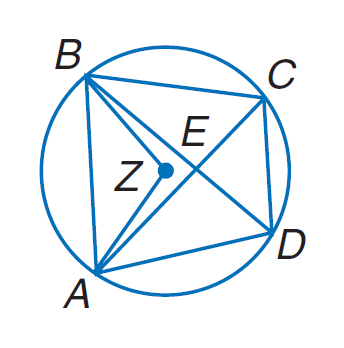Question: Quadrilateral A B C D is inscribed in \odot Z such that m \angle B Z A = 104, m \widehat C B = 94, and A B \parallel D C. Find m \widehat B A.
Choices:
A. 36
B. 90
C. 104
D. 120
Answer with the letter. Answer: C Question: Quadrilateral A B C D is inscribed in \odot Z such that m \angle B Z A = 104, m \widehat C B = 94, and A B \parallel D C. Find m \angle B D A.
Choices:
A. 36
B. 52
C. 94
D. 104
Answer with the letter. Answer: B Question: Quadrilateral A B C D is inscribed in \odot Z such that m \angle B Z A = 104, m \widehat C B = 94, and A B \parallel D C. Find m \widehat A D C.
Choices:
A. 36
B. 90
C. 120
D. 162
Answer with the letter. Answer: D 